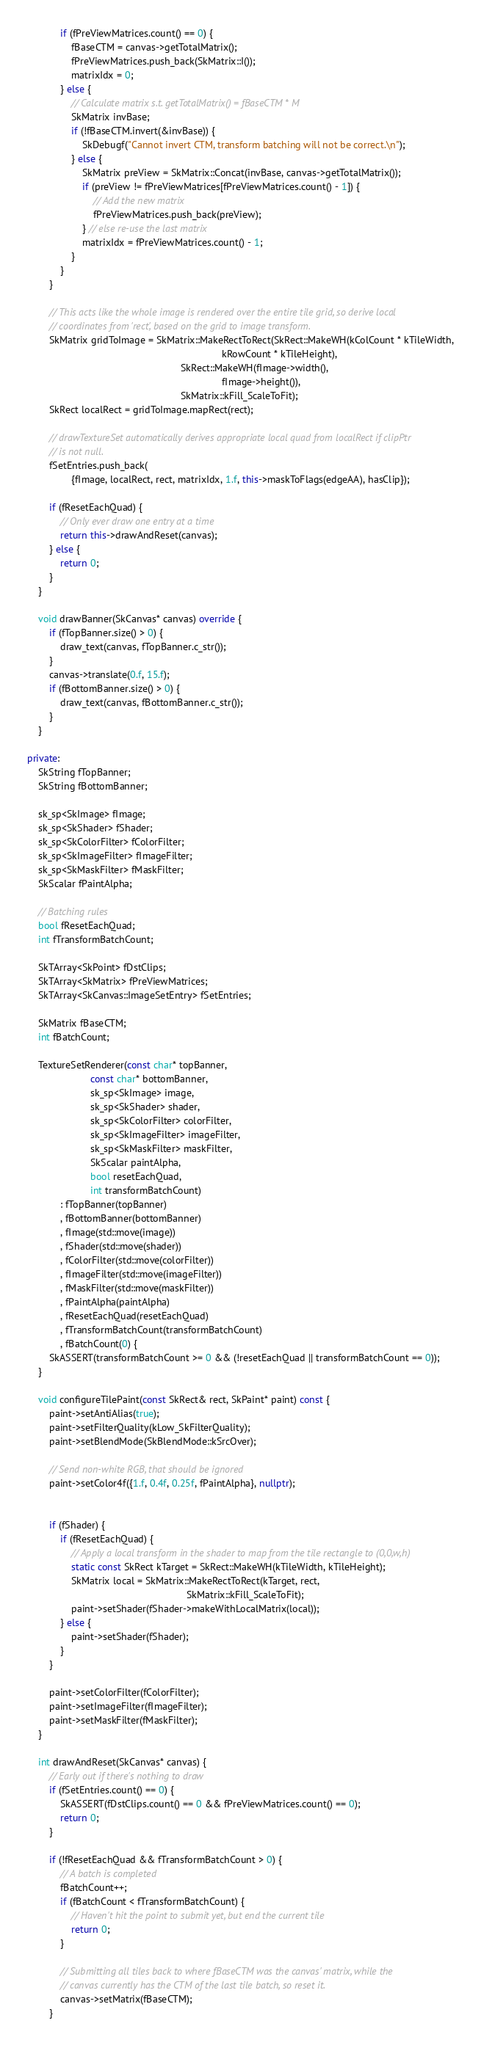<code> <loc_0><loc_0><loc_500><loc_500><_C++_>            if (fPreViewMatrices.count() == 0) {
                fBaseCTM = canvas->getTotalMatrix();
                fPreViewMatrices.push_back(SkMatrix::I());
                matrixIdx = 0;
            } else {
                // Calculate matrix s.t. getTotalMatrix() = fBaseCTM * M
                SkMatrix invBase;
                if (!fBaseCTM.invert(&invBase)) {
                    SkDebugf("Cannot invert CTM, transform batching will not be correct.\n");
                } else {
                    SkMatrix preView = SkMatrix::Concat(invBase, canvas->getTotalMatrix());
                    if (preView != fPreViewMatrices[fPreViewMatrices.count() - 1]) {
                        // Add the new matrix
                        fPreViewMatrices.push_back(preView);
                    } // else re-use the last matrix
                    matrixIdx = fPreViewMatrices.count() - 1;
                }
            }
        }

        // This acts like the whole image is rendered over the entire tile grid, so derive local
        // coordinates from 'rect', based on the grid to image transform.
        SkMatrix gridToImage = SkMatrix::MakeRectToRect(SkRect::MakeWH(kColCount * kTileWidth,
                                                                       kRowCount * kTileHeight),
                                                        SkRect::MakeWH(fImage->width(),
                                                                       fImage->height()),
                                                        SkMatrix::kFill_ScaleToFit);
        SkRect localRect = gridToImage.mapRect(rect);

        // drawTextureSet automatically derives appropriate local quad from localRect if clipPtr
        // is not null.
        fSetEntries.push_back(
                {fImage, localRect, rect, matrixIdx, 1.f, this->maskToFlags(edgeAA), hasClip});

        if (fResetEachQuad) {
            // Only ever draw one entry at a time
            return this->drawAndReset(canvas);
        } else {
            return 0;
        }
    }

    void drawBanner(SkCanvas* canvas) override {
        if (fTopBanner.size() > 0) {
            draw_text(canvas, fTopBanner.c_str());
        }
        canvas->translate(0.f, 15.f);
        if (fBottomBanner.size() > 0) {
            draw_text(canvas, fBottomBanner.c_str());
        }
    }

private:
    SkString fTopBanner;
    SkString fBottomBanner;

    sk_sp<SkImage> fImage;
    sk_sp<SkShader> fShader;
    sk_sp<SkColorFilter> fColorFilter;
    sk_sp<SkImageFilter> fImageFilter;
    sk_sp<SkMaskFilter> fMaskFilter;
    SkScalar fPaintAlpha;

    // Batching rules
    bool fResetEachQuad;
    int fTransformBatchCount;

    SkTArray<SkPoint> fDstClips;
    SkTArray<SkMatrix> fPreViewMatrices;
    SkTArray<SkCanvas::ImageSetEntry> fSetEntries;

    SkMatrix fBaseCTM;
    int fBatchCount;

    TextureSetRenderer(const char* topBanner,
                       const char* bottomBanner,
                       sk_sp<SkImage> image,
                       sk_sp<SkShader> shader,
                       sk_sp<SkColorFilter> colorFilter,
                       sk_sp<SkImageFilter> imageFilter,
                       sk_sp<SkMaskFilter> maskFilter,
                       SkScalar paintAlpha,
                       bool resetEachQuad,
                       int transformBatchCount)
            : fTopBanner(topBanner)
            , fBottomBanner(bottomBanner)
            , fImage(std::move(image))
            , fShader(std::move(shader))
            , fColorFilter(std::move(colorFilter))
            , fImageFilter(std::move(imageFilter))
            , fMaskFilter(std::move(maskFilter))
            , fPaintAlpha(paintAlpha)
            , fResetEachQuad(resetEachQuad)
            , fTransformBatchCount(transformBatchCount)
            , fBatchCount(0) {
        SkASSERT(transformBatchCount >= 0 && (!resetEachQuad || transformBatchCount == 0));
    }

    void configureTilePaint(const SkRect& rect, SkPaint* paint) const {
        paint->setAntiAlias(true);
        paint->setFilterQuality(kLow_SkFilterQuality);
        paint->setBlendMode(SkBlendMode::kSrcOver);

        // Send non-white RGB, that should be ignored
        paint->setColor4f({1.f, 0.4f, 0.25f, fPaintAlpha}, nullptr);


        if (fShader) {
            if (fResetEachQuad) {
                // Apply a local transform in the shader to map from the tile rectangle to (0,0,w,h)
                static const SkRect kTarget = SkRect::MakeWH(kTileWidth, kTileHeight);
                SkMatrix local = SkMatrix::MakeRectToRect(kTarget, rect,
                                                          SkMatrix::kFill_ScaleToFit);
                paint->setShader(fShader->makeWithLocalMatrix(local));
            } else {
                paint->setShader(fShader);
            }
        }

        paint->setColorFilter(fColorFilter);
        paint->setImageFilter(fImageFilter);
        paint->setMaskFilter(fMaskFilter);
    }

    int drawAndReset(SkCanvas* canvas) {
        // Early out if there's nothing to draw
        if (fSetEntries.count() == 0) {
            SkASSERT(fDstClips.count() == 0 && fPreViewMatrices.count() == 0);
            return 0;
        }

        if (!fResetEachQuad && fTransformBatchCount > 0) {
            // A batch is completed
            fBatchCount++;
            if (fBatchCount < fTransformBatchCount) {
                // Haven't hit the point to submit yet, but end the current tile
                return 0;
            }

            // Submitting all tiles back to where fBaseCTM was the canvas' matrix, while the
            // canvas currently has the CTM of the last tile batch, so reset it.
            canvas->setMatrix(fBaseCTM);
        }
</code> 